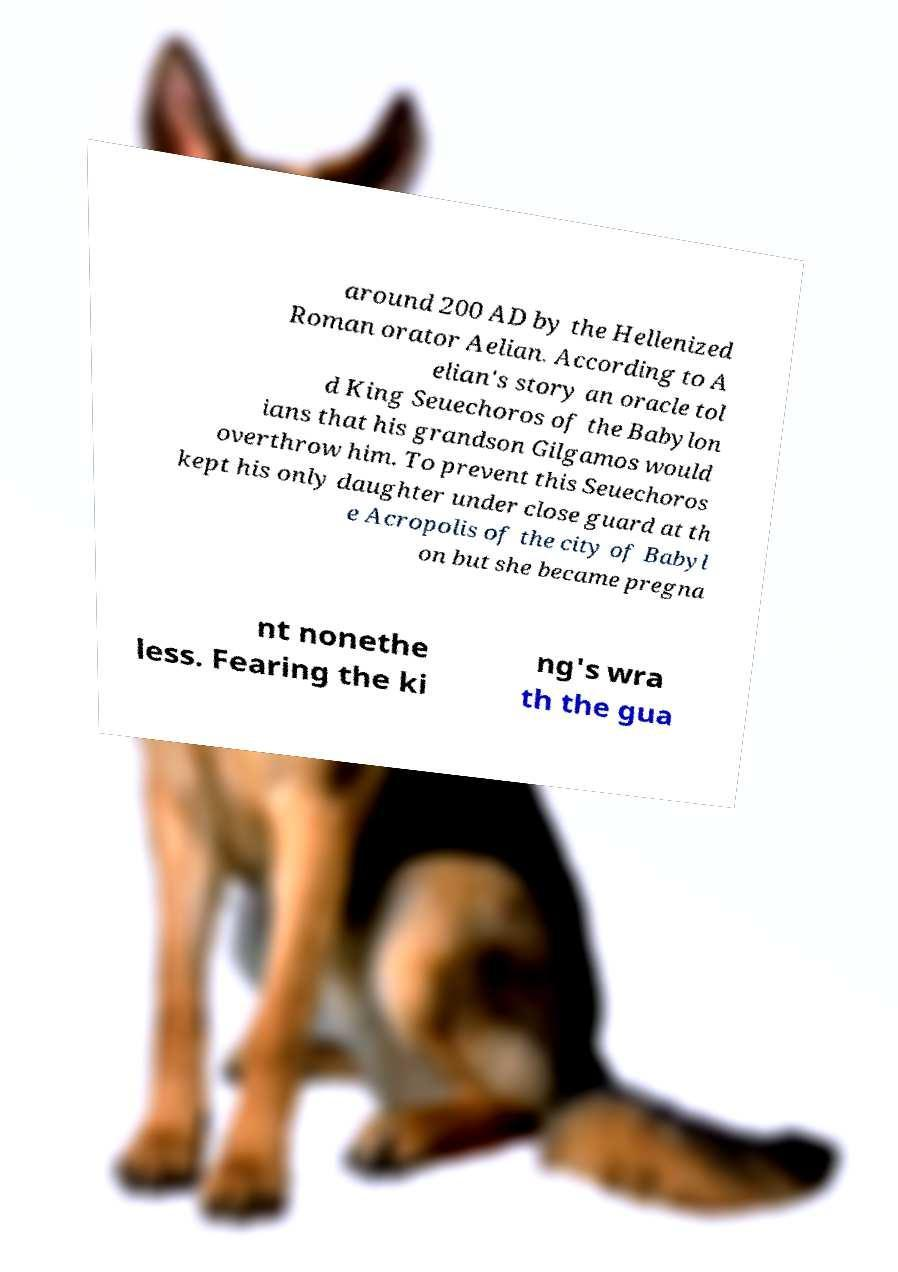Could you assist in decoding the text presented in this image and type it out clearly? around 200 AD by the Hellenized Roman orator Aelian. According to A elian's story an oracle tol d King Seuechoros of the Babylon ians that his grandson Gilgamos would overthrow him. To prevent this Seuechoros kept his only daughter under close guard at th e Acropolis of the city of Babyl on but she became pregna nt nonethe less. Fearing the ki ng's wra th the gua 